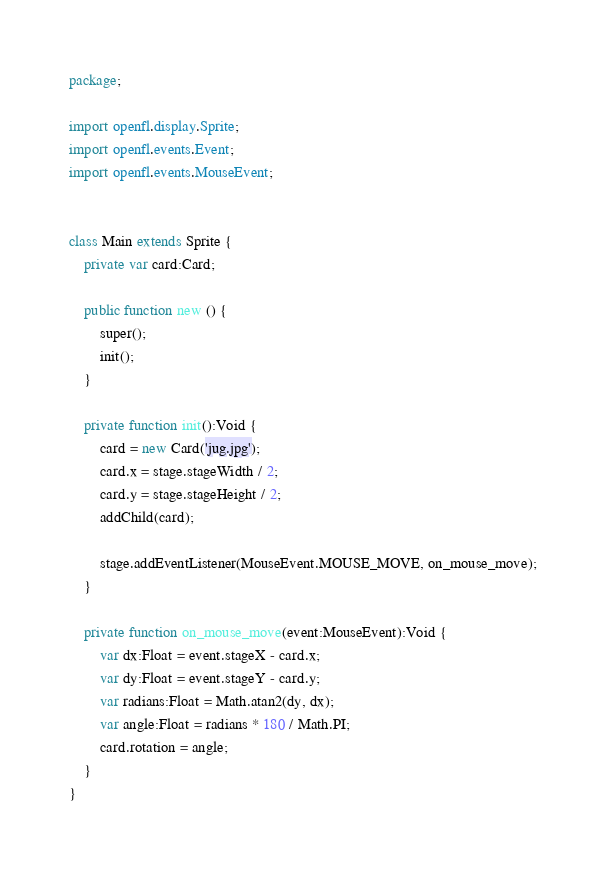Convert code to text. <code><loc_0><loc_0><loc_500><loc_500><_Haxe_>package;

import openfl.display.Sprite;
import openfl.events.Event;
import openfl.events.MouseEvent;


class Main extends Sprite {
	private var card:Card;

	public function new () {
		super();
		init();
	}

	private function init():Void {
		card = new Card('jug.jpg');
		card.x = stage.stageWidth / 2;
		card.y = stage.stageHeight / 2;
		addChild(card);

		stage.addEventListener(MouseEvent.MOUSE_MOVE, on_mouse_move);
	}

	private function on_mouse_move(event:MouseEvent):Void {
		var dx:Float = event.stageX - card.x;
		var dy:Float = event.stageY - card.y;
		var radians:Float = Math.atan2(dy, dx);
		var angle:Float = radians * 180 / Math.PI;
		card.rotation = angle;
	}
}
</code> 